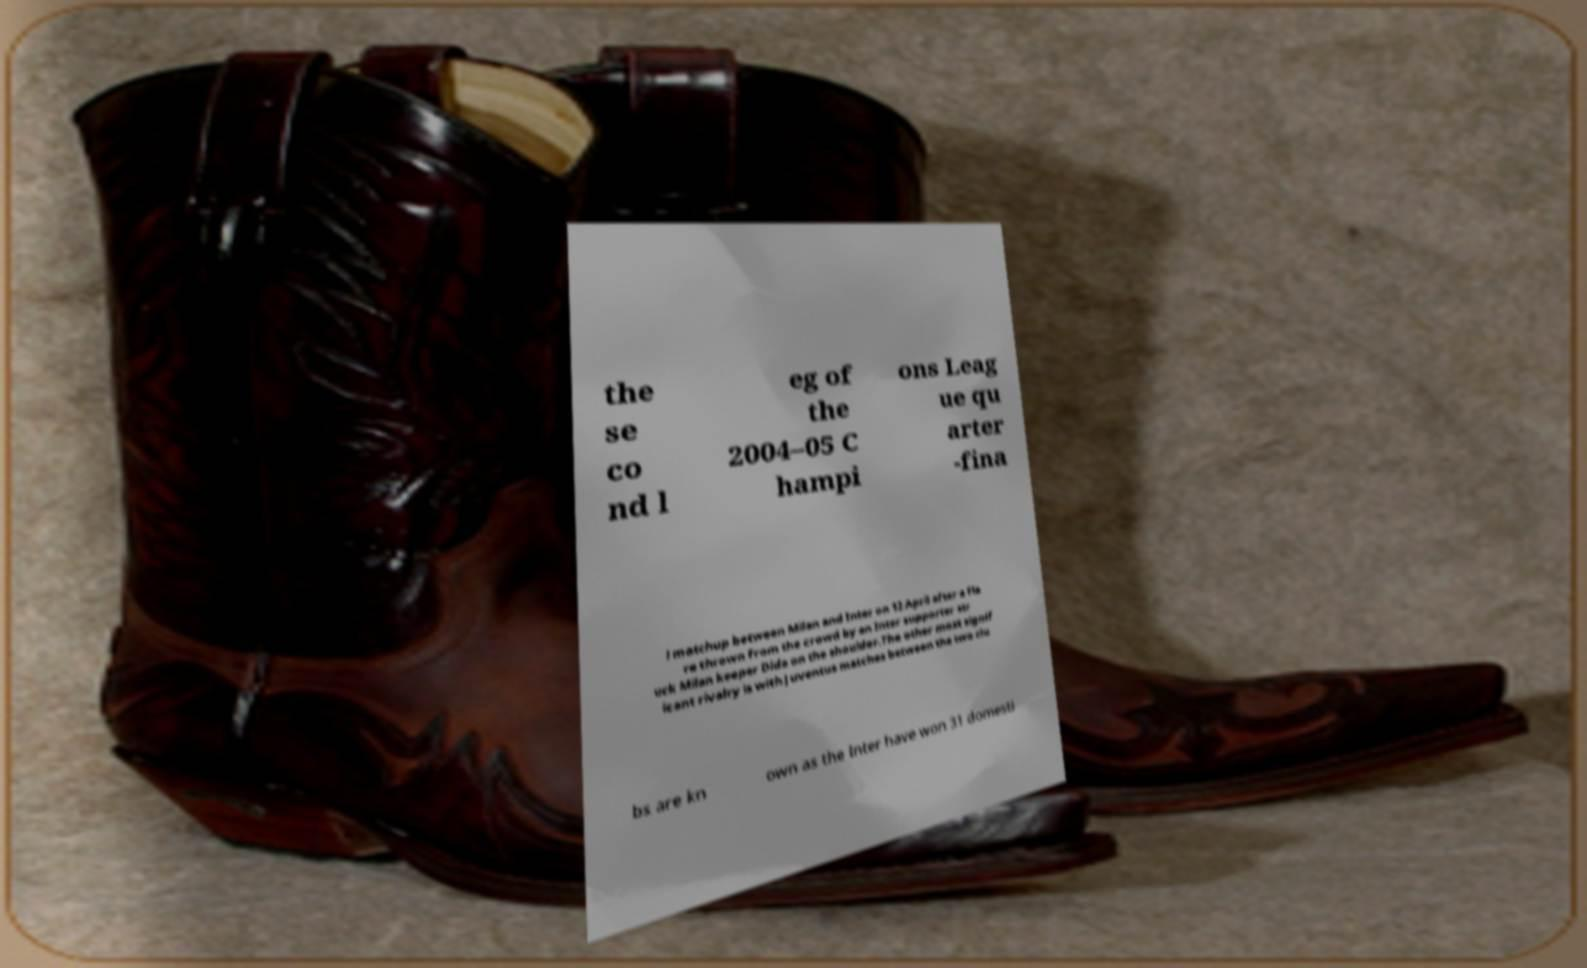I need the written content from this picture converted into text. Can you do that? the se co nd l eg of the 2004–05 C hampi ons Leag ue qu arter -fina l matchup between Milan and Inter on 12 April after a fla re thrown from the crowd by an Inter supporter str uck Milan keeper Dida on the shoulder.The other most signif icant rivalry is with Juventus matches between the two clu bs are kn own as the Inter have won 31 domesti 